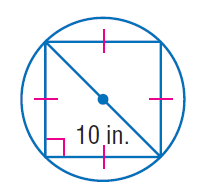Question: Find the exact circumference of the circle.
Choices:
A. 10
B. 25
C. 10 \pi
D. 10 \pi \sqrt { 2 }
Answer with the letter. Answer: D 